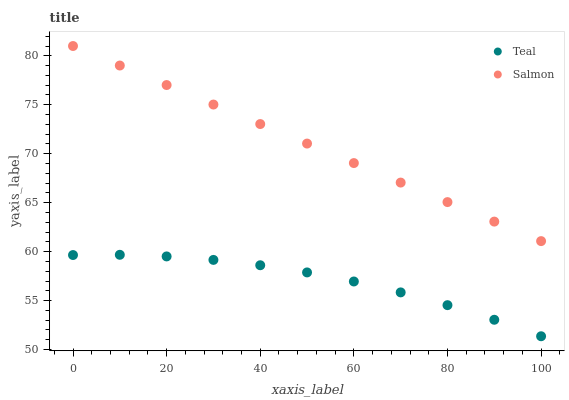Does Teal have the minimum area under the curve?
Answer yes or no. Yes. Does Salmon have the maximum area under the curve?
Answer yes or no. Yes. Does Teal have the maximum area under the curve?
Answer yes or no. No. Is Salmon the smoothest?
Answer yes or no. Yes. Is Teal the roughest?
Answer yes or no. Yes. Is Teal the smoothest?
Answer yes or no. No. Does Teal have the lowest value?
Answer yes or no. Yes. Does Salmon have the highest value?
Answer yes or no. Yes. Does Teal have the highest value?
Answer yes or no. No. Is Teal less than Salmon?
Answer yes or no. Yes. Is Salmon greater than Teal?
Answer yes or no. Yes. Does Teal intersect Salmon?
Answer yes or no. No. 